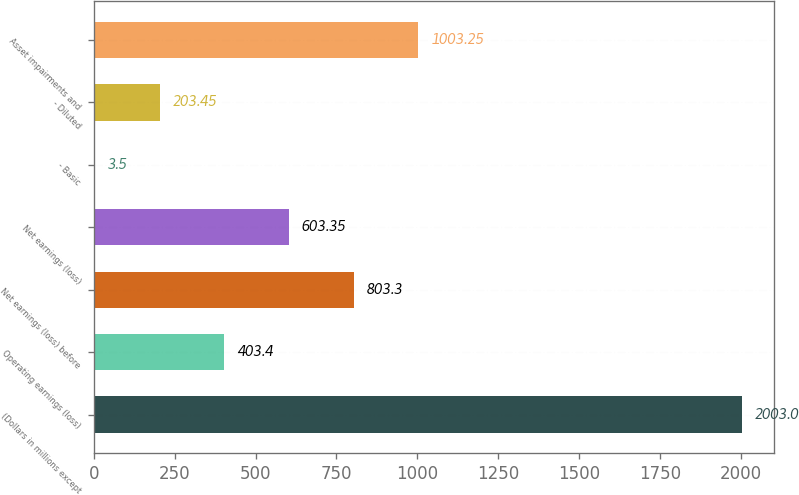Convert chart. <chart><loc_0><loc_0><loc_500><loc_500><bar_chart><fcel>(Dollars in millions except<fcel>Operating earnings (loss)<fcel>Net earnings (loss) before<fcel>Net earnings (loss)<fcel>- Basic<fcel>- Diluted<fcel>Asset impairments and<nl><fcel>2003<fcel>403.4<fcel>803.3<fcel>603.35<fcel>3.5<fcel>203.45<fcel>1003.25<nl></chart> 